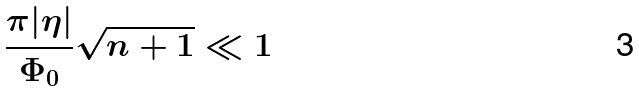Convert formula to latex. <formula><loc_0><loc_0><loc_500><loc_500>\frac { \pi | \eta | } { \Phi _ { 0 } } \sqrt { n + 1 } \ll 1</formula> 